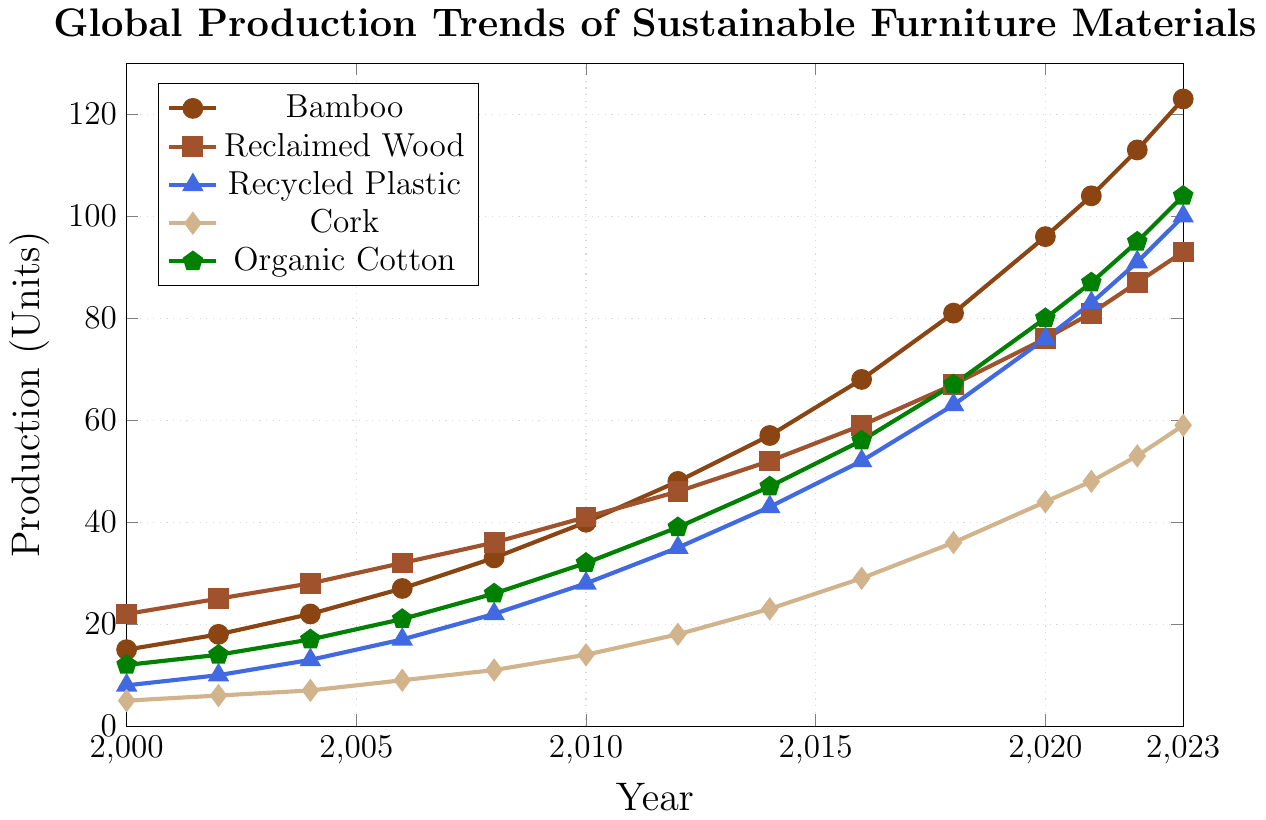What's the trend for Bamboo production from 2000 to 2023? By looking at the line representing Bamboo's production from 2000 to 2023, we observe that it consistently increases each year, indicating a steady upward trend in the production of Bamboo.
Answer: Steady upward trend Which material had the highest production in 2023? In 2023, the material with the highest production value can be identified by looking at the plot. Bamboo reached 123 units, which is higher than any other material listed.
Answer: Bamboo How does the production of Recycled Plastic in 2020 compare to that in 2008? To answer this, we need to compare the data points for Recycled Plastic in 2020 and 2008. In 2008, the production was 22 units, and in 2020, it was 76 units. Therefore, the production of Recycled Plastic in 2020 is significantly higher than in 2008.
Answer: Higher in 2020 What is the difference in production between Organic Cotton and Cork in 2016? Look for the production values of Organic Cotton and Cork in 2016, which are 56 and 29 units, respectively. The difference is 56 - 29.
Answer: 27 units Which material saw the largest increase in production from 2000 to 2023? Compare the increase in production for each material from 2000 to 2023 by subtracting the 2000 value from the 2023 value for each material. Bamboo increased by 123 - 15 = 108 units, reclaimed Wood by 93 - 22 = 71 units, recycled Plastic by 100 - 8 = 92 units, Cork by 59 - 5 = 54 units, and Organic Cotton by 104 - 12 = 92 units. Bamboo has the largest increase.
Answer: Bamboo During which period was the growth in Bamboo production the greatest? By inspecting the slope of the Bamboo production line, we can see that the steepest incline occurs between 2018 and 2020, jumping from 81 to 96 units. The largest growth is calculated by comparing consecutive intervals.
Answer: 2018 to 2020 What's the average production of Reclaimed Wood from 2000 to 2023? To find the average production, sum up all the annual production values of Reclaimed Wood and then divide by the number of years. The sum is (22 + 25 + 28 + 32 + 36 + 41 + 46 + 52 + 59 + 67 + 76 + 81 + 87 + 93) = 745. Divide this by 14 (the number of data points).
Answer: 53.21 units What is the combined production of all materials in 2010? To find the combined production, sum up the production values of all materials in 2010: Bamboo (40), Reclaimed Wood (41), Recycled Plastic (28), Cork (14), and Organic Cotton (32). The sum is 40 + 41 + 28 + 14 + 32.
Answer: 155 units In which year did Organic Cotton's production first exceed 50 units? Look at the plot for Organic Cotton, find the year when production exceeds 50 units for the first time. This happens in 2016.
Answer: 2016 